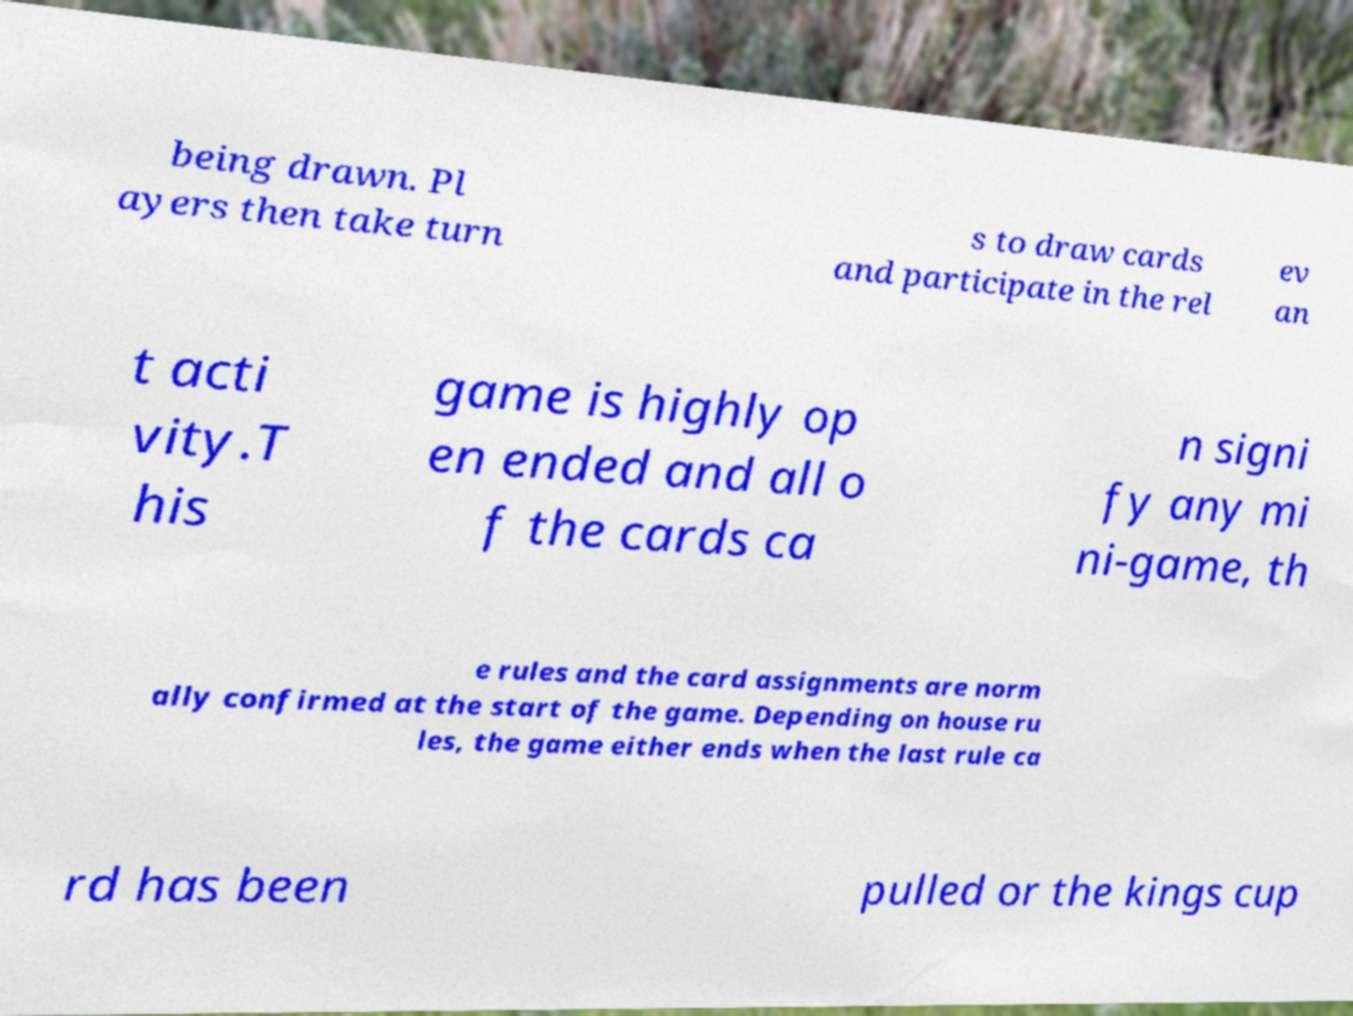What messages or text are displayed in this image? I need them in a readable, typed format. being drawn. Pl ayers then take turn s to draw cards and participate in the rel ev an t acti vity.T his game is highly op en ended and all o f the cards ca n signi fy any mi ni-game, th e rules and the card assignments are norm ally confirmed at the start of the game. Depending on house ru les, the game either ends when the last rule ca rd has been pulled or the kings cup 